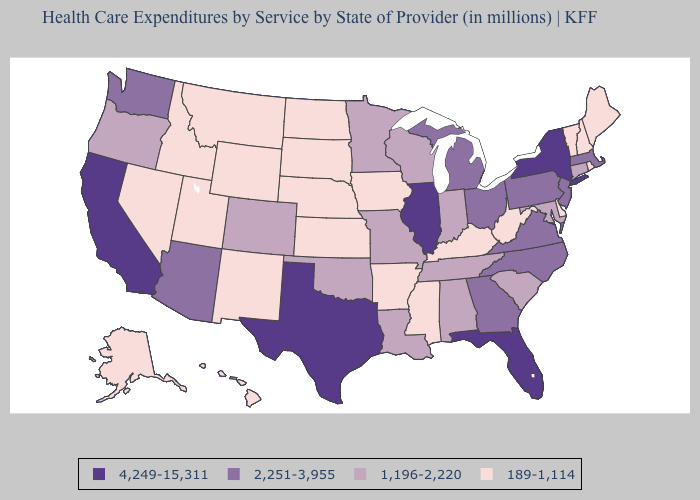Does Alabama have the highest value in the USA?
Short answer required. No. Does Kansas have the same value as Maine?
Write a very short answer. Yes. Among the states that border Florida , which have the lowest value?
Write a very short answer. Alabama. Does Rhode Island have the highest value in the Northeast?
Short answer required. No. Name the states that have a value in the range 4,249-15,311?
Short answer required. California, Florida, Illinois, New York, Texas. What is the value of Alaska?
Be succinct. 189-1,114. Name the states that have a value in the range 4,249-15,311?
Concise answer only. California, Florida, Illinois, New York, Texas. What is the value of Connecticut?
Keep it brief. 1,196-2,220. What is the value of New York?
Concise answer only. 4,249-15,311. Which states have the lowest value in the Northeast?
Give a very brief answer. Maine, New Hampshire, Rhode Island, Vermont. Does Missouri have a higher value than Delaware?
Quick response, please. Yes. Name the states that have a value in the range 1,196-2,220?
Keep it brief. Alabama, Colorado, Connecticut, Indiana, Louisiana, Maryland, Minnesota, Missouri, Oklahoma, Oregon, South Carolina, Tennessee, Wisconsin. Is the legend a continuous bar?
Answer briefly. No. Does the first symbol in the legend represent the smallest category?
Keep it brief. No. What is the value of Indiana?
Quick response, please. 1,196-2,220. 